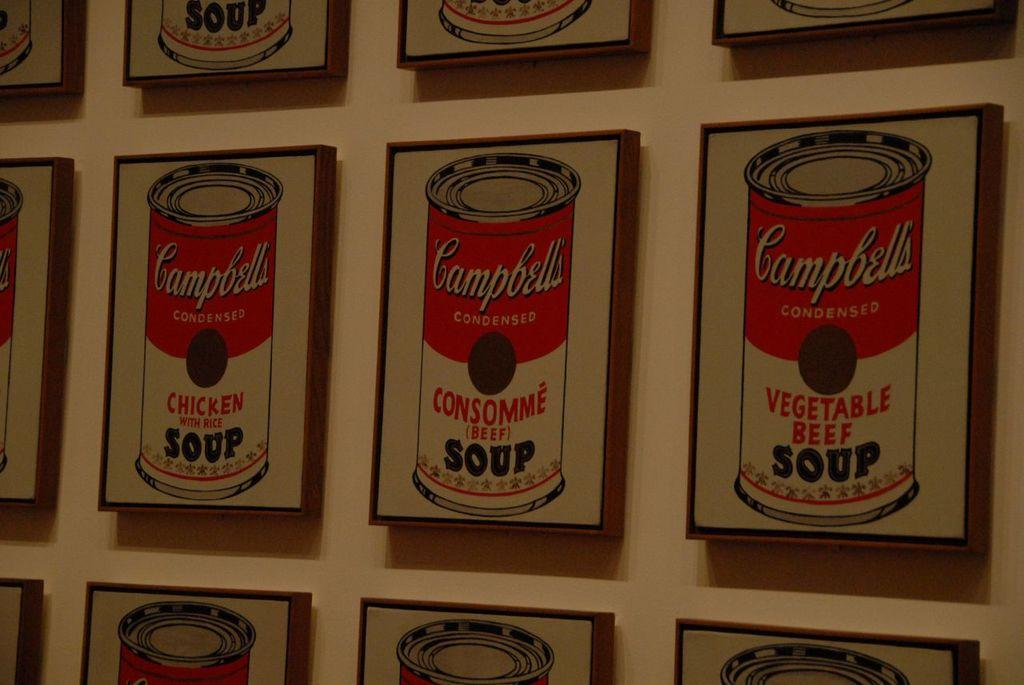Provide a one-sentence caption for the provided image. Many paintings of Campbell's soup hang on a wall. 